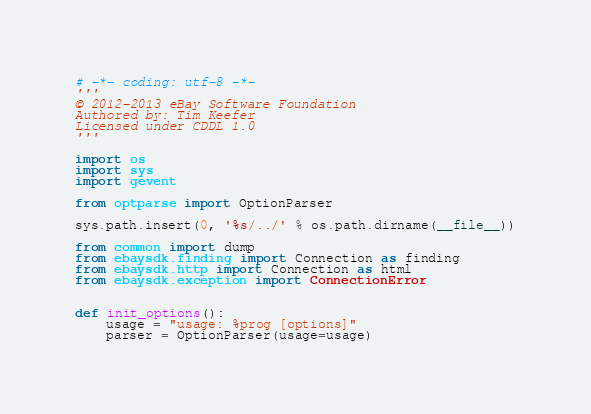Convert code to text. <code><loc_0><loc_0><loc_500><loc_500><_Python_># -*- coding: utf-8 -*-
'''
© 2012-2013 eBay Software Foundation
Authored by: Tim Keefer
Licensed under CDDL 1.0
'''

import os
import sys
import gevent

from optparse import OptionParser

sys.path.insert(0, '%s/../' % os.path.dirname(__file__))

from common import dump
from ebaysdk.finding import Connection as finding
from ebaysdk.http import Connection as html
from ebaysdk.exception import ConnectionError


def init_options():
    usage = "usage: %prog [options]"
    parser = OptionParser(usage=usage)
</code> 